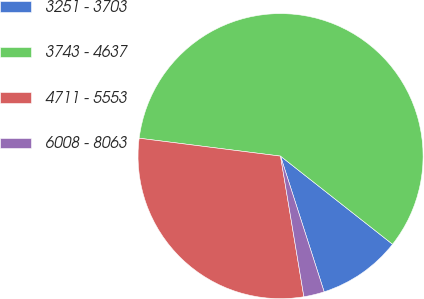<chart> <loc_0><loc_0><loc_500><loc_500><pie_chart><fcel>3251 - 3703<fcel>3743 - 4637<fcel>4711 - 5553<fcel>6008 - 8063<nl><fcel>9.44%<fcel>58.6%<fcel>29.62%<fcel>2.33%<nl></chart> 